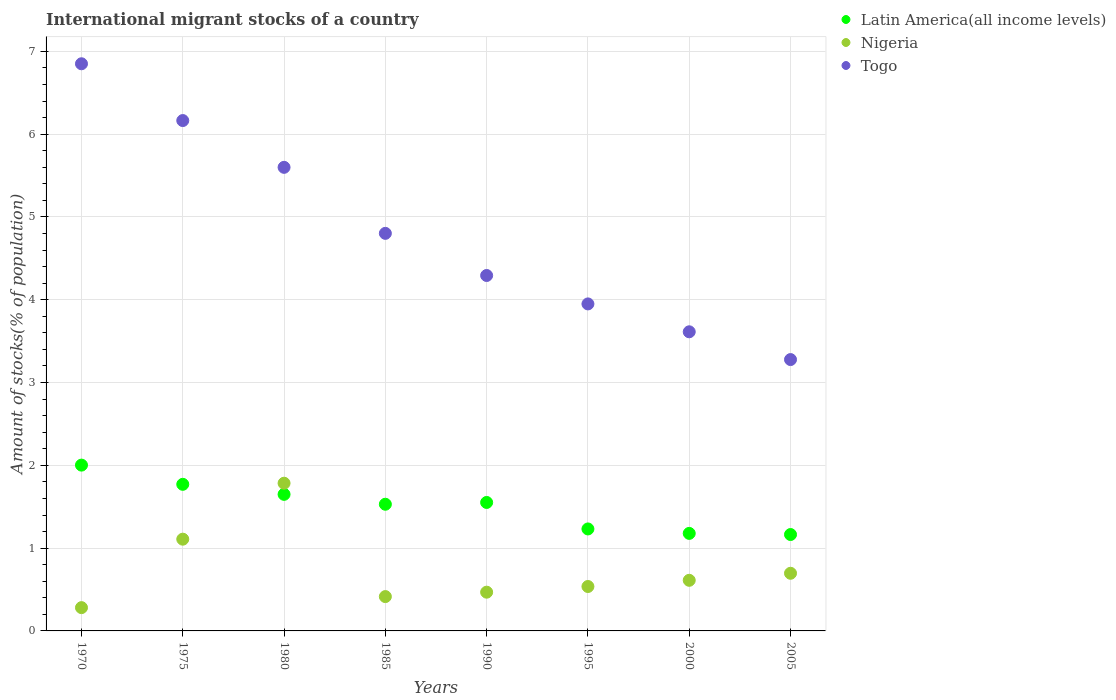Is the number of dotlines equal to the number of legend labels?
Your answer should be compact. Yes. What is the amount of stocks in in Latin America(all income levels) in 1985?
Your response must be concise. 1.53. Across all years, what is the maximum amount of stocks in in Latin America(all income levels)?
Give a very brief answer. 2. Across all years, what is the minimum amount of stocks in in Togo?
Provide a short and direct response. 3.28. What is the total amount of stocks in in Togo in the graph?
Offer a very short reply. 38.55. What is the difference between the amount of stocks in in Togo in 1995 and that in 2005?
Offer a terse response. 0.67. What is the difference between the amount of stocks in in Latin America(all income levels) in 2005 and the amount of stocks in in Nigeria in 1980?
Your answer should be very brief. -0.62. What is the average amount of stocks in in Togo per year?
Make the answer very short. 4.82. In the year 1995, what is the difference between the amount of stocks in in Togo and amount of stocks in in Latin America(all income levels)?
Make the answer very short. 2.72. What is the ratio of the amount of stocks in in Togo in 1990 to that in 1995?
Your answer should be very brief. 1.09. Is the difference between the amount of stocks in in Togo in 1970 and 1975 greater than the difference between the amount of stocks in in Latin America(all income levels) in 1970 and 1975?
Offer a terse response. Yes. What is the difference between the highest and the second highest amount of stocks in in Nigeria?
Give a very brief answer. 0.68. What is the difference between the highest and the lowest amount of stocks in in Latin America(all income levels)?
Ensure brevity in your answer.  0.84. In how many years, is the amount of stocks in in Togo greater than the average amount of stocks in in Togo taken over all years?
Make the answer very short. 3. Is the sum of the amount of stocks in in Nigeria in 1990 and 2005 greater than the maximum amount of stocks in in Togo across all years?
Ensure brevity in your answer.  No. Is the amount of stocks in in Togo strictly greater than the amount of stocks in in Nigeria over the years?
Provide a short and direct response. Yes. How many dotlines are there?
Make the answer very short. 3. How many years are there in the graph?
Offer a terse response. 8. What is the difference between two consecutive major ticks on the Y-axis?
Offer a very short reply. 1. Does the graph contain any zero values?
Offer a very short reply. No. Does the graph contain grids?
Make the answer very short. Yes. Where does the legend appear in the graph?
Keep it short and to the point. Top right. How many legend labels are there?
Your response must be concise. 3. What is the title of the graph?
Keep it short and to the point. International migrant stocks of a country. Does "Madagascar" appear as one of the legend labels in the graph?
Give a very brief answer. No. What is the label or title of the Y-axis?
Ensure brevity in your answer.  Amount of stocks(% of population). What is the Amount of stocks(% of population) in Latin America(all income levels) in 1970?
Offer a very short reply. 2. What is the Amount of stocks(% of population) of Nigeria in 1970?
Make the answer very short. 0.28. What is the Amount of stocks(% of population) of Togo in 1970?
Make the answer very short. 6.85. What is the Amount of stocks(% of population) of Latin America(all income levels) in 1975?
Offer a very short reply. 1.77. What is the Amount of stocks(% of population) in Nigeria in 1975?
Offer a very short reply. 1.11. What is the Amount of stocks(% of population) in Togo in 1975?
Make the answer very short. 6.16. What is the Amount of stocks(% of population) in Latin America(all income levels) in 1980?
Your response must be concise. 1.65. What is the Amount of stocks(% of population) of Nigeria in 1980?
Ensure brevity in your answer.  1.78. What is the Amount of stocks(% of population) of Togo in 1980?
Your answer should be very brief. 5.6. What is the Amount of stocks(% of population) of Latin America(all income levels) in 1985?
Your answer should be very brief. 1.53. What is the Amount of stocks(% of population) of Nigeria in 1985?
Offer a very short reply. 0.41. What is the Amount of stocks(% of population) in Togo in 1985?
Your response must be concise. 4.8. What is the Amount of stocks(% of population) in Latin America(all income levels) in 1990?
Ensure brevity in your answer.  1.55. What is the Amount of stocks(% of population) in Nigeria in 1990?
Your response must be concise. 0.47. What is the Amount of stocks(% of population) of Togo in 1990?
Make the answer very short. 4.29. What is the Amount of stocks(% of population) of Latin America(all income levels) in 1995?
Your answer should be compact. 1.23. What is the Amount of stocks(% of population) of Nigeria in 1995?
Provide a short and direct response. 0.54. What is the Amount of stocks(% of population) of Togo in 1995?
Give a very brief answer. 3.95. What is the Amount of stocks(% of population) of Latin America(all income levels) in 2000?
Provide a succinct answer. 1.18. What is the Amount of stocks(% of population) of Nigeria in 2000?
Provide a succinct answer. 0.61. What is the Amount of stocks(% of population) of Togo in 2000?
Keep it short and to the point. 3.61. What is the Amount of stocks(% of population) of Latin America(all income levels) in 2005?
Make the answer very short. 1.16. What is the Amount of stocks(% of population) of Nigeria in 2005?
Your answer should be very brief. 0.7. What is the Amount of stocks(% of population) in Togo in 2005?
Provide a short and direct response. 3.28. Across all years, what is the maximum Amount of stocks(% of population) in Latin America(all income levels)?
Provide a short and direct response. 2. Across all years, what is the maximum Amount of stocks(% of population) of Nigeria?
Offer a terse response. 1.78. Across all years, what is the maximum Amount of stocks(% of population) in Togo?
Ensure brevity in your answer.  6.85. Across all years, what is the minimum Amount of stocks(% of population) in Latin America(all income levels)?
Your response must be concise. 1.16. Across all years, what is the minimum Amount of stocks(% of population) of Nigeria?
Provide a succinct answer. 0.28. Across all years, what is the minimum Amount of stocks(% of population) of Togo?
Provide a short and direct response. 3.28. What is the total Amount of stocks(% of population) of Latin America(all income levels) in the graph?
Provide a succinct answer. 12.08. What is the total Amount of stocks(% of population) in Togo in the graph?
Ensure brevity in your answer.  38.55. What is the difference between the Amount of stocks(% of population) in Latin America(all income levels) in 1970 and that in 1975?
Provide a succinct answer. 0.23. What is the difference between the Amount of stocks(% of population) of Nigeria in 1970 and that in 1975?
Your answer should be very brief. -0.83. What is the difference between the Amount of stocks(% of population) of Togo in 1970 and that in 1975?
Make the answer very short. 0.69. What is the difference between the Amount of stocks(% of population) of Latin America(all income levels) in 1970 and that in 1980?
Keep it short and to the point. 0.35. What is the difference between the Amount of stocks(% of population) in Nigeria in 1970 and that in 1980?
Provide a short and direct response. -1.5. What is the difference between the Amount of stocks(% of population) in Togo in 1970 and that in 1980?
Your answer should be compact. 1.25. What is the difference between the Amount of stocks(% of population) of Latin America(all income levels) in 1970 and that in 1985?
Keep it short and to the point. 0.47. What is the difference between the Amount of stocks(% of population) in Nigeria in 1970 and that in 1985?
Give a very brief answer. -0.13. What is the difference between the Amount of stocks(% of population) of Togo in 1970 and that in 1985?
Your answer should be very brief. 2.05. What is the difference between the Amount of stocks(% of population) in Latin America(all income levels) in 1970 and that in 1990?
Make the answer very short. 0.45. What is the difference between the Amount of stocks(% of population) of Nigeria in 1970 and that in 1990?
Your response must be concise. -0.19. What is the difference between the Amount of stocks(% of population) of Togo in 1970 and that in 1990?
Ensure brevity in your answer.  2.56. What is the difference between the Amount of stocks(% of population) in Latin America(all income levels) in 1970 and that in 1995?
Make the answer very short. 0.77. What is the difference between the Amount of stocks(% of population) in Nigeria in 1970 and that in 1995?
Offer a terse response. -0.26. What is the difference between the Amount of stocks(% of population) of Togo in 1970 and that in 1995?
Offer a terse response. 2.9. What is the difference between the Amount of stocks(% of population) of Latin America(all income levels) in 1970 and that in 2000?
Give a very brief answer. 0.82. What is the difference between the Amount of stocks(% of population) of Nigeria in 1970 and that in 2000?
Ensure brevity in your answer.  -0.33. What is the difference between the Amount of stocks(% of population) in Togo in 1970 and that in 2000?
Your answer should be compact. 3.24. What is the difference between the Amount of stocks(% of population) of Latin America(all income levels) in 1970 and that in 2005?
Make the answer very short. 0.84. What is the difference between the Amount of stocks(% of population) in Nigeria in 1970 and that in 2005?
Make the answer very short. -0.42. What is the difference between the Amount of stocks(% of population) in Togo in 1970 and that in 2005?
Provide a succinct answer. 3.57. What is the difference between the Amount of stocks(% of population) of Latin America(all income levels) in 1975 and that in 1980?
Ensure brevity in your answer.  0.12. What is the difference between the Amount of stocks(% of population) of Nigeria in 1975 and that in 1980?
Your response must be concise. -0.68. What is the difference between the Amount of stocks(% of population) in Togo in 1975 and that in 1980?
Give a very brief answer. 0.56. What is the difference between the Amount of stocks(% of population) in Latin America(all income levels) in 1975 and that in 1985?
Keep it short and to the point. 0.24. What is the difference between the Amount of stocks(% of population) of Nigeria in 1975 and that in 1985?
Provide a succinct answer. 0.69. What is the difference between the Amount of stocks(% of population) in Togo in 1975 and that in 1985?
Give a very brief answer. 1.36. What is the difference between the Amount of stocks(% of population) in Latin America(all income levels) in 1975 and that in 1990?
Your response must be concise. 0.22. What is the difference between the Amount of stocks(% of population) of Nigeria in 1975 and that in 1990?
Provide a succinct answer. 0.64. What is the difference between the Amount of stocks(% of population) in Togo in 1975 and that in 1990?
Offer a very short reply. 1.87. What is the difference between the Amount of stocks(% of population) in Latin America(all income levels) in 1975 and that in 1995?
Ensure brevity in your answer.  0.54. What is the difference between the Amount of stocks(% of population) in Nigeria in 1975 and that in 1995?
Ensure brevity in your answer.  0.57. What is the difference between the Amount of stocks(% of population) in Togo in 1975 and that in 1995?
Provide a succinct answer. 2.21. What is the difference between the Amount of stocks(% of population) of Latin America(all income levels) in 1975 and that in 2000?
Provide a short and direct response. 0.59. What is the difference between the Amount of stocks(% of population) of Nigeria in 1975 and that in 2000?
Offer a terse response. 0.5. What is the difference between the Amount of stocks(% of population) of Togo in 1975 and that in 2000?
Offer a very short reply. 2.55. What is the difference between the Amount of stocks(% of population) of Latin America(all income levels) in 1975 and that in 2005?
Offer a terse response. 0.61. What is the difference between the Amount of stocks(% of population) in Nigeria in 1975 and that in 2005?
Make the answer very short. 0.41. What is the difference between the Amount of stocks(% of population) in Togo in 1975 and that in 2005?
Make the answer very short. 2.89. What is the difference between the Amount of stocks(% of population) in Latin America(all income levels) in 1980 and that in 1985?
Your answer should be very brief. 0.12. What is the difference between the Amount of stocks(% of population) in Nigeria in 1980 and that in 1985?
Your answer should be very brief. 1.37. What is the difference between the Amount of stocks(% of population) in Togo in 1980 and that in 1985?
Make the answer very short. 0.8. What is the difference between the Amount of stocks(% of population) of Latin America(all income levels) in 1980 and that in 1990?
Provide a succinct answer. 0.1. What is the difference between the Amount of stocks(% of population) of Nigeria in 1980 and that in 1990?
Provide a short and direct response. 1.32. What is the difference between the Amount of stocks(% of population) of Togo in 1980 and that in 1990?
Give a very brief answer. 1.31. What is the difference between the Amount of stocks(% of population) in Latin America(all income levels) in 1980 and that in 1995?
Provide a succinct answer. 0.42. What is the difference between the Amount of stocks(% of population) in Nigeria in 1980 and that in 1995?
Give a very brief answer. 1.25. What is the difference between the Amount of stocks(% of population) in Togo in 1980 and that in 1995?
Ensure brevity in your answer.  1.65. What is the difference between the Amount of stocks(% of population) in Latin America(all income levels) in 1980 and that in 2000?
Your answer should be very brief. 0.47. What is the difference between the Amount of stocks(% of population) in Nigeria in 1980 and that in 2000?
Offer a very short reply. 1.17. What is the difference between the Amount of stocks(% of population) of Togo in 1980 and that in 2000?
Offer a very short reply. 1.99. What is the difference between the Amount of stocks(% of population) of Latin America(all income levels) in 1980 and that in 2005?
Ensure brevity in your answer.  0.49. What is the difference between the Amount of stocks(% of population) of Nigeria in 1980 and that in 2005?
Provide a short and direct response. 1.09. What is the difference between the Amount of stocks(% of population) in Togo in 1980 and that in 2005?
Your response must be concise. 2.32. What is the difference between the Amount of stocks(% of population) of Latin America(all income levels) in 1985 and that in 1990?
Your answer should be compact. -0.02. What is the difference between the Amount of stocks(% of population) of Nigeria in 1985 and that in 1990?
Give a very brief answer. -0.05. What is the difference between the Amount of stocks(% of population) in Togo in 1985 and that in 1990?
Make the answer very short. 0.51. What is the difference between the Amount of stocks(% of population) of Latin America(all income levels) in 1985 and that in 1995?
Offer a very short reply. 0.3. What is the difference between the Amount of stocks(% of population) of Nigeria in 1985 and that in 1995?
Keep it short and to the point. -0.12. What is the difference between the Amount of stocks(% of population) in Togo in 1985 and that in 1995?
Your answer should be compact. 0.85. What is the difference between the Amount of stocks(% of population) in Latin America(all income levels) in 1985 and that in 2000?
Your answer should be very brief. 0.35. What is the difference between the Amount of stocks(% of population) in Nigeria in 1985 and that in 2000?
Offer a very short reply. -0.2. What is the difference between the Amount of stocks(% of population) in Togo in 1985 and that in 2000?
Provide a short and direct response. 1.19. What is the difference between the Amount of stocks(% of population) of Latin America(all income levels) in 1985 and that in 2005?
Offer a very short reply. 0.37. What is the difference between the Amount of stocks(% of population) in Nigeria in 1985 and that in 2005?
Offer a very short reply. -0.28. What is the difference between the Amount of stocks(% of population) of Togo in 1985 and that in 2005?
Make the answer very short. 1.52. What is the difference between the Amount of stocks(% of population) of Latin America(all income levels) in 1990 and that in 1995?
Provide a short and direct response. 0.32. What is the difference between the Amount of stocks(% of population) in Nigeria in 1990 and that in 1995?
Provide a succinct answer. -0.07. What is the difference between the Amount of stocks(% of population) in Togo in 1990 and that in 1995?
Offer a very short reply. 0.34. What is the difference between the Amount of stocks(% of population) in Latin America(all income levels) in 1990 and that in 2000?
Make the answer very short. 0.37. What is the difference between the Amount of stocks(% of population) in Nigeria in 1990 and that in 2000?
Your answer should be very brief. -0.14. What is the difference between the Amount of stocks(% of population) of Togo in 1990 and that in 2000?
Your response must be concise. 0.68. What is the difference between the Amount of stocks(% of population) in Latin America(all income levels) in 1990 and that in 2005?
Provide a short and direct response. 0.39. What is the difference between the Amount of stocks(% of population) of Nigeria in 1990 and that in 2005?
Provide a succinct answer. -0.23. What is the difference between the Amount of stocks(% of population) in Togo in 1990 and that in 2005?
Ensure brevity in your answer.  1.02. What is the difference between the Amount of stocks(% of population) in Latin America(all income levels) in 1995 and that in 2000?
Offer a very short reply. 0.05. What is the difference between the Amount of stocks(% of population) in Nigeria in 1995 and that in 2000?
Your response must be concise. -0.07. What is the difference between the Amount of stocks(% of population) of Togo in 1995 and that in 2000?
Make the answer very short. 0.34. What is the difference between the Amount of stocks(% of population) of Latin America(all income levels) in 1995 and that in 2005?
Your answer should be compact. 0.07. What is the difference between the Amount of stocks(% of population) in Nigeria in 1995 and that in 2005?
Give a very brief answer. -0.16. What is the difference between the Amount of stocks(% of population) in Togo in 1995 and that in 2005?
Make the answer very short. 0.67. What is the difference between the Amount of stocks(% of population) of Latin America(all income levels) in 2000 and that in 2005?
Your response must be concise. 0.01. What is the difference between the Amount of stocks(% of population) of Nigeria in 2000 and that in 2005?
Provide a short and direct response. -0.09. What is the difference between the Amount of stocks(% of population) in Togo in 2000 and that in 2005?
Provide a short and direct response. 0.34. What is the difference between the Amount of stocks(% of population) of Latin America(all income levels) in 1970 and the Amount of stocks(% of population) of Nigeria in 1975?
Give a very brief answer. 0.89. What is the difference between the Amount of stocks(% of population) in Latin America(all income levels) in 1970 and the Amount of stocks(% of population) in Togo in 1975?
Your response must be concise. -4.16. What is the difference between the Amount of stocks(% of population) of Nigeria in 1970 and the Amount of stocks(% of population) of Togo in 1975?
Ensure brevity in your answer.  -5.88. What is the difference between the Amount of stocks(% of population) in Latin America(all income levels) in 1970 and the Amount of stocks(% of population) in Nigeria in 1980?
Keep it short and to the point. 0.22. What is the difference between the Amount of stocks(% of population) of Latin America(all income levels) in 1970 and the Amount of stocks(% of population) of Togo in 1980?
Provide a short and direct response. -3.6. What is the difference between the Amount of stocks(% of population) of Nigeria in 1970 and the Amount of stocks(% of population) of Togo in 1980?
Your answer should be very brief. -5.32. What is the difference between the Amount of stocks(% of population) of Latin America(all income levels) in 1970 and the Amount of stocks(% of population) of Nigeria in 1985?
Offer a very short reply. 1.59. What is the difference between the Amount of stocks(% of population) in Latin America(all income levels) in 1970 and the Amount of stocks(% of population) in Togo in 1985?
Make the answer very short. -2.8. What is the difference between the Amount of stocks(% of population) in Nigeria in 1970 and the Amount of stocks(% of population) in Togo in 1985?
Keep it short and to the point. -4.52. What is the difference between the Amount of stocks(% of population) in Latin America(all income levels) in 1970 and the Amount of stocks(% of population) in Nigeria in 1990?
Your answer should be very brief. 1.53. What is the difference between the Amount of stocks(% of population) in Latin America(all income levels) in 1970 and the Amount of stocks(% of population) in Togo in 1990?
Give a very brief answer. -2.29. What is the difference between the Amount of stocks(% of population) of Nigeria in 1970 and the Amount of stocks(% of population) of Togo in 1990?
Provide a short and direct response. -4.01. What is the difference between the Amount of stocks(% of population) in Latin America(all income levels) in 1970 and the Amount of stocks(% of population) in Nigeria in 1995?
Give a very brief answer. 1.47. What is the difference between the Amount of stocks(% of population) in Latin America(all income levels) in 1970 and the Amount of stocks(% of population) in Togo in 1995?
Your answer should be very brief. -1.95. What is the difference between the Amount of stocks(% of population) of Nigeria in 1970 and the Amount of stocks(% of population) of Togo in 1995?
Give a very brief answer. -3.67. What is the difference between the Amount of stocks(% of population) in Latin America(all income levels) in 1970 and the Amount of stocks(% of population) in Nigeria in 2000?
Your answer should be very brief. 1.39. What is the difference between the Amount of stocks(% of population) in Latin America(all income levels) in 1970 and the Amount of stocks(% of population) in Togo in 2000?
Your answer should be compact. -1.61. What is the difference between the Amount of stocks(% of population) in Nigeria in 1970 and the Amount of stocks(% of population) in Togo in 2000?
Your answer should be very brief. -3.33. What is the difference between the Amount of stocks(% of population) of Latin America(all income levels) in 1970 and the Amount of stocks(% of population) of Nigeria in 2005?
Keep it short and to the point. 1.31. What is the difference between the Amount of stocks(% of population) of Latin America(all income levels) in 1970 and the Amount of stocks(% of population) of Togo in 2005?
Provide a succinct answer. -1.27. What is the difference between the Amount of stocks(% of population) in Nigeria in 1970 and the Amount of stocks(% of population) in Togo in 2005?
Keep it short and to the point. -3. What is the difference between the Amount of stocks(% of population) in Latin America(all income levels) in 1975 and the Amount of stocks(% of population) in Nigeria in 1980?
Offer a terse response. -0.01. What is the difference between the Amount of stocks(% of population) of Latin America(all income levels) in 1975 and the Amount of stocks(% of population) of Togo in 1980?
Ensure brevity in your answer.  -3.83. What is the difference between the Amount of stocks(% of population) in Nigeria in 1975 and the Amount of stocks(% of population) in Togo in 1980?
Keep it short and to the point. -4.49. What is the difference between the Amount of stocks(% of population) in Latin America(all income levels) in 1975 and the Amount of stocks(% of population) in Nigeria in 1985?
Ensure brevity in your answer.  1.36. What is the difference between the Amount of stocks(% of population) of Latin America(all income levels) in 1975 and the Amount of stocks(% of population) of Togo in 1985?
Your answer should be compact. -3.03. What is the difference between the Amount of stocks(% of population) in Nigeria in 1975 and the Amount of stocks(% of population) in Togo in 1985?
Make the answer very short. -3.69. What is the difference between the Amount of stocks(% of population) of Latin America(all income levels) in 1975 and the Amount of stocks(% of population) of Nigeria in 1990?
Make the answer very short. 1.3. What is the difference between the Amount of stocks(% of population) in Latin America(all income levels) in 1975 and the Amount of stocks(% of population) in Togo in 1990?
Ensure brevity in your answer.  -2.52. What is the difference between the Amount of stocks(% of population) in Nigeria in 1975 and the Amount of stocks(% of population) in Togo in 1990?
Provide a succinct answer. -3.18. What is the difference between the Amount of stocks(% of population) of Latin America(all income levels) in 1975 and the Amount of stocks(% of population) of Nigeria in 1995?
Your answer should be compact. 1.23. What is the difference between the Amount of stocks(% of population) in Latin America(all income levels) in 1975 and the Amount of stocks(% of population) in Togo in 1995?
Your response must be concise. -2.18. What is the difference between the Amount of stocks(% of population) in Nigeria in 1975 and the Amount of stocks(% of population) in Togo in 1995?
Your response must be concise. -2.84. What is the difference between the Amount of stocks(% of population) in Latin America(all income levels) in 1975 and the Amount of stocks(% of population) in Nigeria in 2000?
Provide a succinct answer. 1.16. What is the difference between the Amount of stocks(% of population) of Latin America(all income levels) in 1975 and the Amount of stocks(% of population) of Togo in 2000?
Provide a short and direct response. -1.84. What is the difference between the Amount of stocks(% of population) of Nigeria in 1975 and the Amount of stocks(% of population) of Togo in 2000?
Ensure brevity in your answer.  -2.5. What is the difference between the Amount of stocks(% of population) of Latin America(all income levels) in 1975 and the Amount of stocks(% of population) of Nigeria in 2005?
Your answer should be very brief. 1.07. What is the difference between the Amount of stocks(% of population) of Latin America(all income levels) in 1975 and the Amount of stocks(% of population) of Togo in 2005?
Your response must be concise. -1.51. What is the difference between the Amount of stocks(% of population) of Nigeria in 1975 and the Amount of stocks(% of population) of Togo in 2005?
Your response must be concise. -2.17. What is the difference between the Amount of stocks(% of population) in Latin America(all income levels) in 1980 and the Amount of stocks(% of population) in Nigeria in 1985?
Ensure brevity in your answer.  1.23. What is the difference between the Amount of stocks(% of population) of Latin America(all income levels) in 1980 and the Amount of stocks(% of population) of Togo in 1985?
Your answer should be compact. -3.15. What is the difference between the Amount of stocks(% of population) of Nigeria in 1980 and the Amount of stocks(% of population) of Togo in 1985?
Provide a short and direct response. -3.02. What is the difference between the Amount of stocks(% of population) of Latin America(all income levels) in 1980 and the Amount of stocks(% of population) of Nigeria in 1990?
Provide a short and direct response. 1.18. What is the difference between the Amount of stocks(% of population) of Latin America(all income levels) in 1980 and the Amount of stocks(% of population) of Togo in 1990?
Offer a very short reply. -2.64. What is the difference between the Amount of stocks(% of population) in Nigeria in 1980 and the Amount of stocks(% of population) in Togo in 1990?
Ensure brevity in your answer.  -2.51. What is the difference between the Amount of stocks(% of population) in Latin America(all income levels) in 1980 and the Amount of stocks(% of population) in Nigeria in 1995?
Your answer should be very brief. 1.11. What is the difference between the Amount of stocks(% of population) of Latin America(all income levels) in 1980 and the Amount of stocks(% of population) of Togo in 1995?
Provide a short and direct response. -2.3. What is the difference between the Amount of stocks(% of population) in Nigeria in 1980 and the Amount of stocks(% of population) in Togo in 1995?
Ensure brevity in your answer.  -2.17. What is the difference between the Amount of stocks(% of population) in Latin America(all income levels) in 1980 and the Amount of stocks(% of population) in Nigeria in 2000?
Make the answer very short. 1.04. What is the difference between the Amount of stocks(% of population) in Latin America(all income levels) in 1980 and the Amount of stocks(% of population) in Togo in 2000?
Offer a terse response. -1.96. What is the difference between the Amount of stocks(% of population) in Nigeria in 1980 and the Amount of stocks(% of population) in Togo in 2000?
Make the answer very short. -1.83. What is the difference between the Amount of stocks(% of population) of Latin America(all income levels) in 1980 and the Amount of stocks(% of population) of Nigeria in 2005?
Offer a terse response. 0.95. What is the difference between the Amount of stocks(% of population) of Latin America(all income levels) in 1980 and the Amount of stocks(% of population) of Togo in 2005?
Make the answer very short. -1.63. What is the difference between the Amount of stocks(% of population) in Nigeria in 1980 and the Amount of stocks(% of population) in Togo in 2005?
Keep it short and to the point. -1.49. What is the difference between the Amount of stocks(% of population) of Latin America(all income levels) in 1985 and the Amount of stocks(% of population) of Nigeria in 1990?
Provide a short and direct response. 1.06. What is the difference between the Amount of stocks(% of population) in Latin America(all income levels) in 1985 and the Amount of stocks(% of population) in Togo in 1990?
Provide a short and direct response. -2.76. What is the difference between the Amount of stocks(% of population) in Nigeria in 1985 and the Amount of stocks(% of population) in Togo in 1990?
Provide a short and direct response. -3.88. What is the difference between the Amount of stocks(% of population) in Latin America(all income levels) in 1985 and the Amount of stocks(% of population) in Nigeria in 1995?
Your answer should be compact. 0.99. What is the difference between the Amount of stocks(% of population) of Latin America(all income levels) in 1985 and the Amount of stocks(% of population) of Togo in 1995?
Offer a terse response. -2.42. What is the difference between the Amount of stocks(% of population) in Nigeria in 1985 and the Amount of stocks(% of population) in Togo in 1995?
Provide a succinct answer. -3.53. What is the difference between the Amount of stocks(% of population) in Latin America(all income levels) in 1985 and the Amount of stocks(% of population) in Nigeria in 2000?
Keep it short and to the point. 0.92. What is the difference between the Amount of stocks(% of population) of Latin America(all income levels) in 1985 and the Amount of stocks(% of population) of Togo in 2000?
Offer a terse response. -2.08. What is the difference between the Amount of stocks(% of population) in Nigeria in 1985 and the Amount of stocks(% of population) in Togo in 2000?
Give a very brief answer. -3.2. What is the difference between the Amount of stocks(% of population) of Latin America(all income levels) in 1985 and the Amount of stocks(% of population) of Nigeria in 2005?
Your answer should be compact. 0.83. What is the difference between the Amount of stocks(% of population) of Latin America(all income levels) in 1985 and the Amount of stocks(% of population) of Togo in 2005?
Offer a very short reply. -1.75. What is the difference between the Amount of stocks(% of population) of Nigeria in 1985 and the Amount of stocks(% of population) of Togo in 2005?
Give a very brief answer. -2.86. What is the difference between the Amount of stocks(% of population) in Latin America(all income levels) in 1990 and the Amount of stocks(% of population) in Nigeria in 1995?
Offer a terse response. 1.02. What is the difference between the Amount of stocks(% of population) of Latin America(all income levels) in 1990 and the Amount of stocks(% of population) of Togo in 1995?
Offer a very short reply. -2.4. What is the difference between the Amount of stocks(% of population) in Nigeria in 1990 and the Amount of stocks(% of population) in Togo in 1995?
Offer a terse response. -3.48. What is the difference between the Amount of stocks(% of population) of Latin America(all income levels) in 1990 and the Amount of stocks(% of population) of Nigeria in 2000?
Provide a short and direct response. 0.94. What is the difference between the Amount of stocks(% of population) of Latin America(all income levels) in 1990 and the Amount of stocks(% of population) of Togo in 2000?
Your answer should be very brief. -2.06. What is the difference between the Amount of stocks(% of population) of Nigeria in 1990 and the Amount of stocks(% of population) of Togo in 2000?
Keep it short and to the point. -3.14. What is the difference between the Amount of stocks(% of population) in Latin America(all income levels) in 1990 and the Amount of stocks(% of population) in Nigeria in 2005?
Ensure brevity in your answer.  0.86. What is the difference between the Amount of stocks(% of population) of Latin America(all income levels) in 1990 and the Amount of stocks(% of population) of Togo in 2005?
Make the answer very short. -1.73. What is the difference between the Amount of stocks(% of population) of Nigeria in 1990 and the Amount of stocks(% of population) of Togo in 2005?
Make the answer very short. -2.81. What is the difference between the Amount of stocks(% of population) in Latin America(all income levels) in 1995 and the Amount of stocks(% of population) in Nigeria in 2000?
Offer a terse response. 0.62. What is the difference between the Amount of stocks(% of population) in Latin America(all income levels) in 1995 and the Amount of stocks(% of population) in Togo in 2000?
Your answer should be very brief. -2.38. What is the difference between the Amount of stocks(% of population) of Nigeria in 1995 and the Amount of stocks(% of population) of Togo in 2000?
Make the answer very short. -3.08. What is the difference between the Amount of stocks(% of population) of Latin America(all income levels) in 1995 and the Amount of stocks(% of population) of Nigeria in 2005?
Your response must be concise. 0.54. What is the difference between the Amount of stocks(% of population) in Latin America(all income levels) in 1995 and the Amount of stocks(% of population) in Togo in 2005?
Keep it short and to the point. -2.05. What is the difference between the Amount of stocks(% of population) of Nigeria in 1995 and the Amount of stocks(% of population) of Togo in 2005?
Give a very brief answer. -2.74. What is the difference between the Amount of stocks(% of population) in Latin America(all income levels) in 2000 and the Amount of stocks(% of population) in Nigeria in 2005?
Offer a terse response. 0.48. What is the difference between the Amount of stocks(% of population) in Latin America(all income levels) in 2000 and the Amount of stocks(% of population) in Togo in 2005?
Offer a terse response. -2.1. What is the difference between the Amount of stocks(% of population) of Nigeria in 2000 and the Amount of stocks(% of population) of Togo in 2005?
Your answer should be very brief. -2.67. What is the average Amount of stocks(% of population) of Latin America(all income levels) per year?
Make the answer very short. 1.51. What is the average Amount of stocks(% of population) in Nigeria per year?
Ensure brevity in your answer.  0.74. What is the average Amount of stocks(% of population) of Togo per year?
Give a very brief answer. 4.82. In the year 1970, what is the difference between the Amount of stocks(% of population) in Latin America(all income levels) and Amount of stocks(% of population) in Nigeria?
Provide a short and direct response. 1.72. In the year 1970, what is the difference between the Amount of stocks(% of population) in Latin America(all income levels) and Amount of stocks(% of population) in Togo?
Offer a very short reply. -4.85. In the year 1970, what is the difference between the Amount of stocks(% of population) in Nigeria and Amount of stocks(% of population) in Togo?
Keep it short and to the point. -6.57. In the year 1975, what is the difference between the Amount of stocks(% of population) of Latin America(all income levels) and Amount of stocks(% of population) of Nigeria?
Your response must be concise. 0.66. In the year 1975, what is the difference between the Amount of stocks(% of population) of Latin America(all income levels) and Amount of stocks(% of population) of Togo?
Offer a very short reply. -4.39. In the year 1975, what is the difference between the Amount of stocks(% of population) in Nigeria and Amount of stocks(% of population) in Togo?
Your response must be concise. -5.06. In the year 1980, what is the difference between the Amount of stocks(% of population) in Latin America(all income levels) and Amount of stocks(% of population) in Nigeria?
Give a very brief answer. -0.13. In the year 1980, what is the difference between the Amount of stocks(% of population) in Latin America(all income levels) and Amount of stocks(% of population) in Togo?
Your answer should be compact. -3.95. In the year 1980, what is the difference between the Amount of stocks(% of population) in Nigeria and Amount of stocks(% of population) in Togo?
Offer a terse response. -3.82. In the year 1985, what is the difference between the Amount of stocks(% of population) in Latin America(all income levels) and Amount of stocks(% of population) in Nigeria?
Offer a very short reply. 1.12. In the year 1985, what is the difference between the Amount of stocks(% of population) in Latin America(all income levels) and Amount of stocks(% of population) in Togo?
Your answer should be very brief. -3.27. In the year 1985, what is the difference between the Amount of stocks(% of population) of Nigeria and Amount of stocks(% of population) of Togo?
Provide a succinct answer. -4.39. In the year 1990, what is the difference between the Amount of stocks(% of population) in Latin America(all income levels) and Amount of stocks(% of population) in Nigeria?
Provide a short and direct response. 1.08. In the year 1990, what is the difference between the Amount of stocks(% of population) in Latin America(all income levels) and Amount of stocks(% of population) in Togo?
Ensure brevity in your answer.  -2.74. In the year 1990, what is the difference between the Amount of stocks(% of population) of Nigeria and Amount of stocks(% of population) of Togo?
Make the answer very short. -3.83. In the year 1995, what is the difference between the Amount of stocks(% of population) in Latin America(all income levels) and Amount of stocks(% of population) in Nigeria?
Offer a very short reply. 0.7. In the year 1995, what is the difference between the Amount of stocks(% of population) of Latin America(all income levels) and Amount of stocks(% of population) of Togo?
Keep it short and to the point. -2.72. In the year 1995, what is the difference between the Amount of stocks(% of population) of Nigeria and Amount of stocks(% of population) of Togo?
Your response must be concise. -3.41. In the year 2000, what is the difference between the Amount of stocks(% of population) of Latin America(all income levels) and Amount of stocks(% of population) of Nigeria?
Your response must be concise. 0.57. In the year 2000, what is the difference between the Amount of stocks(% of population) in Latin America(all income levels) and Amount of stocks(% of population) in Togo?
Give a very brief answer. -2.43. In the year 2000, what is the difference between the Amount of stocks(% of population) in Nigeria and Amount of stocks(% of population) in Togo?
Give a very brief answer. -3. In the year 2005, what is the difference between the Amount of stocks(% of population) in Latin America(all income levels) and Amount of stocks(% of population) in Nigeria?
Your response must be concise. 0.47. In the year 2005, what is the difference between the Amount of stocks(% of population) in Latin America(all income levels) and Amount of stocks(% of population) in Togo?
Ensure brevity in your answer.  -2.11. In the year 2005, what is the difference between the Amount of stocks(% of population) of Nigeria and Amount of stocks(% of population) of Togo?
Give a very brief answer. -2.58. What is the ratio of the Amount of stocks(% of population) of Latin America(all income levels) in 1970 to that in 1975?
Provide a short and direct response. 1.13. What is the ratio of the Amount of stocks(% of population) of Nigeria in 1970 to that in 1975?
Provide a short and direct response. 0.25. What is the ratio of the Amount of stocks(% of population) in Togo in 1970 to that in 1975?
Offer a terse response. 1.11. What is the ratio of the Amount of stocks(% of population) of Latin America(all income levels) in 1970 to that in 1980?
Provide a succinct answer. 1.21. What is the ratio of the Amount of stocks(% of population) in Nigeria in 1970 to that in 1980?
Offer a terse response. 0.16. What is the ratio of the Amount of stocks(% of population) of Togo in 1970 to that in 1980?
Your response must be concise. 1.22. What is the ratio of the Amount of stocks(% of population) of Latin America(all income levels) in 1970 to that in 1985?
Provide a short and direct response. 1.31. What is the ratio of the Amount of stocks(% of population) of Nigeria in 1970 to that in 1985?
Keep it short and to the point. 0.68. What is the ratio of the Amount of stocks(% of population) of Togo in 1970 to that in 1985?
Your response must be concise. 1.43. What is the ratio of the Amount of stocks(% of population) of Latin America(all income levels) in 1970 to that in 1990?
Offer a very short reply. 1.29. What is the ratio of the Amount of stocks(% of population) in Nigeria in 1970 to that in 1990?
Make the answer very short. 0.6. What is the ratio of the Amount of stocks(% of population) in Togo in 1970 to that in 1990?
Provide a short and direct response. 1.6. What is the ratio of the Amount of stocks(% of population) of Latin America(all income levels) in 1970 to that in 1995?
Offer a very short reply. 1.63. What is the ratio of the Amount of stocks(% of population) in Nigeria in 1970 to that in 1995?
Give a very brief answer. 0.52. What is the ratio of the Amount of stocks(% of population) of Togo in 1970 to that in 1995?
Ensure brevity in your answer.  1.73. What is the ratio of the Amount of stocks(% of population) in Nigeria in 1970 to that in 2000?
Offer a terse response. 0.46. What is the ratio of the Amount of stocks(% of population) of Togo in 1970 to that in 2000?
Offer a terse response. 1.9. What is the ratio of the Amount of stocks(% of population) of Latin America(all income levels) in 1970 to that in 2005?
Make the answer very short. 1.72. What is the ratio of the Amount of stocks(% of population) of Nigeria in 1970 to that in 2005?
Offer a very short reply. 0.4. What is the ratio of the Amount of stocks(% of population) of Togo in 1970 to that in 2005?
Ensure brevity in your answer.  2.09. What is the ratio of the Amount of stocks(% of population) in Latin America(all income levels) in 1975 to that in 1980?
Ensure brevity in your answer.  1.07. What is the ratio of the Amount of stocks(% of population) in Nigeria in 1975 to that in 1980?
Provide a succinct answer. 0.62. What is the ratio of the Amount of stocks(% of population) of Togo in 1975 to that in 1980?
Make the answer very short. 1.1. What is the ratio of the Amount of stocks(% of population) of Latin America(all income levels) in 1975 to that in 1985?
Provide a short and direct response. 1.16. What is the ratio of the Amount of stocks(% of population) in Nigeria in 1975 to that in 1985?
Provide a succinct answer. 2.67. What is the ratio of the Amount of stocks(% of population) in Togo in 1975 to that in 1985?
Provide a short and direct response. 1.28. What is the ratio of the Amount of stocks(% of population) of Latin America(all income levels) in 1975 to that in 1990?
Offer a terse response. 1.14. What is the ratio of the Amount of stocks(% of population) of Nigeria in 1975 to that in 1990?
Provide a succinct answer. 2.37. What is the ratio of the Amount of stocks(% of population) in Togo in 1975 to that in 1990?
Your answer should be very brief. 1.44. What is the ratio of the Amount of stocks(% of population) of Latin America(all income levels) in 1975 to that in 1995?
Provide a succinct answer. 1.44. What is the ratio of the Amount of stocks(% of population) in Nigeria in 1975 to that in 1995?
Make the answer very short. 2.07. What is the ratio of the Amount of stocks(% of population) of Togo in 1975 to that in 1995?
Ensure brevity in your answer.  1.56. What is the ratio of the Amount of stocks(% of population) of Latin America(all income levels) in 1975 to that in 2000?
Provide a short and direct response. 1.5. What is the ratio of the Amount of stocks(% of population) of Nigeria in 1975 to that in 2000?
Provide a succinct answer. 1.81. What is the ratio of the Amount of stocks(% of population) of Togo in 1975 to that in 2000?
Offer a terse response. 1.71. What is the ratio of the Amount of stocks(% of population) in Latin America(all income levels) in 1975 to that in 2005?
Your answer should be compact. 1.52. What is the ratio of the Amount of stocks(% of population) of Nigeria in 1975 to that in 2005?
Provide a short and direct response. 1.59. What is the ratio of the Amount of stocks(% of population) of Togo in 1975 to that in 2005?
Your answer should be compact. 1.88. What is the ratio of the Amount of stocks(% of population) in Latin America(all income levels) in 1980 to that in 1985?
Keep it short and to the point. 1.08. What is the ratio of the Amount of stocks(% of population) of Nigeria in 1980 to that in 1985?
Your answer should be compact. 4.3. What is the ratio of the Amount of stocks(% of population) in Togo in 1980 to that in 1985?
Offer a terse response. 1.17. What is the ratio of the Amount of stocks(% of population) of Latin America(all income levels) in 1980 to that in 1990?
Give a very brief answer. 1.06. What is the ratio of the Amount of stocks(% of population) of Nigeria in 1980 to that in 1990?
Offer a very short reply. 3.81. What is the ratio of the Amount of stocks(% of population) of Togo in 1980 to that in 1990?
Give a very brief answer. 1.3. What is the ratio of the Amount of stocks(% of population) in Latin America(all income levels) in 1980 to that in 1995?
Offer a very short reply. 1.34. What is the ratio of the Amount of stocks(% of population) in Nigeria in 1980 to that in 1995?
Your response must be concise. 3.33. What is the ratio of the Amount of stocks(% of population) in Togo in 1980 to that in 1995?
Your response must be concise. 1.42. What is the ratio of the Amount of stocks(% of population) of Latin America(all income levels) in 1980 to that in 2000?
Your response must be concise. 1.4. What is the ratio of the Amount of stocks(% of population) of Nigeria in 1980 to that in 2000?
Ensure brevity in your answer.  2.92. What is the ratio of the Amount of stocks(% of population) in Togo in 1980 to that in 2000?
Ensure brevity in your answer.  1.55. What is the ratio of the Amount of stocks(% of population) of Latin America(all income levels) in 1980 to that in 2005?
Ensure brevity in your answer.  1.42. What is the ratio of the Amount of stocks(% of population) in Nigeria in 1980 to that in 2005?
Give a very brief answer. 2.56. What is the ratio of the Amount of stocks(% of population) of Togo in 1980 to that in 2005?
Give a very brief answer. 1.71. What is the ratio of the Amount of stocks(% of population) of Latin America(all income levels) in 1985 to that in 1990?
Give a very brief answer. 0.99. What is the ratio of the Amount of stocks(% of population) of Nigeria in 1985 to that in 1990?
Your answer should be compact. 0.89. What is the ratio of the Amount of stocks(% of population) in Togo in 1985 to that in 1990?
Offer a terse response. 1.12. What is the ratio of the Amount of stocks(% of population) of Latin America(all income levels) in 1985 to that in 1995?
Keep it short and to the point. 1.24. What is the ratio of the Amount of stocks(% of population) of Nigeria in 1985 to that in 1995?
Offer a terse response. 0.77. What is the ratio of the Amount of stocks(% of population) in Togo in 1985 to that in 1995?
Your answer should be compact. 1.22. What is the ratio of the Amount of stocks(% of population) in Latin America(all income levels) in 1985 to that in 2000?
Provide a short and direct response. 1.3. What is the ratio of the Amount of stocks(% of population) in Nigeria in 1985 to that in 2000?
Give a very brief answer. 0.68. What is the ratio of the Amount of stocks(% of population) in Togo in 1985 to that in 2000?
Give a very brief answer. 1.33. What is the ratio of the Amount of stocks(% of population) of Latin America(all income levels) in 1985 to that in 2005?
Offer a very short reply. 1.31. What is the ratio of the Amount of stocks(% of population) in Nigeria in 1985 to that in 2005?
Make the answer very short. 0.6. What is the ratio of the Amount of stocks(% of population) in Togo in 1985 to that in 2005?
Your answer should be very brief. 1.47. What is the ratio of the Amount of stocks(% of population) in Latin America(all income levels) in 1990 to that in 1995?
Provide a succinct answer. 1.26. What is the ratio of the Amount of stocks(% of population) in Nigeria in 1990 to that in 1995?
Offer a very short reply. 0.87. What is the ratio of the Amount of stocks(% of population) in Togo in 1990 to that in 1995?
Ensure brevity in your answer.  1.09. What is the ratio of the Amount of stocks(% of population) in Latin America(all income levels) in 1990 to that in 2000?
Offer a very short reply. 1.32. What is the ratio of the Amount of stocks(% of population) of Nigeria in 1990 to that in 2000?
Offer a terse response. 0.77. What is the ratio of the Amount of stocks(% of population) in Togo in 1990 to that in 2000?
Provide a short and direct response. 1.19. What is the ratio of the Amount of stocks(% of population) in Latin America(all income levels) in 1990 to that in 2005?
Give a very brief answer. 1.33. What is the ratio of the Amount of stocks(% of population) of Nigeria in 1990 to that in 2005?
Offer a very short reply. 0.67. What is the ratio of the Amount of stocks(% of population) in Togo in 1990 to that in 2005?
Your response must be concise. 1.31. What is the ratio of the Amount of stocks(% of population) of Latin America(all income levels) in 1995 to that in 2000?
Offer a terse response. 1.05. What is the ratio of the Amount of stocks(% of population) in Nigeria in 1995 to that in 2000?
Offer a terse response. 0.88. What is the ratio of the Amount of stocks(% of population) in Togo in 1995 to that in 2000?
Your answer should be very brief. 1.09. What is the ratio of the Amount of stocks(% of population) in Latin America(all income levels) in 1995 to that in 2005?
Your response must be concise. 1.06. What is the ratio of the Amount of stocks(% of population) of Nigeria in 1995 to that in 2005?
Your answer should be compact. 0.77. What is the ratio of the Amount of stocks(% of population) of Togo in 1995 to that in 2005?
Make the answer very short. 1.21. What is the ratio of the Amount of stocks(% of population) in Latin America(all income levels) in 2000 to that in 2005?
Provide a short and direct response. 1.01. What is the ratio of the Amount of stocks(% of population) of Nigeria in 2000 to that in 2005?
Offer a terse response. 0.88. What is the ratio of the Amount of stocks(% of population) in Togo in 2000 to that in 2005?
Provide a short and direct response. 1.1. What is the difference between the highest and the second highest Amount of stocks(% of population) in Latin America(all income levels)?
Ensure brevity in your answer.  0.23. What is the difference between the highest and the second highest Amount of stocks(% of population) in Nigeria?
Make the answer very short. 0.68. What is the difference between the highest and the second highest Amount of stocks(% of population) of Togo?
Give a very brief answer. 0.69. What is the difference between the highest and the lowest Amount of stocks(% of population) in Latin America(all income levels)?
Provide a succinct answer. 0.84. What is the difference between the highest and the lowest Amount of stocks(% of population) of Nigeria?
Offer a very short reply. 1.5. What is the difference between the highest and the lowest Amount of stocks(% of population) of Togo?
Ensure brevity in your answer.  3.57. 